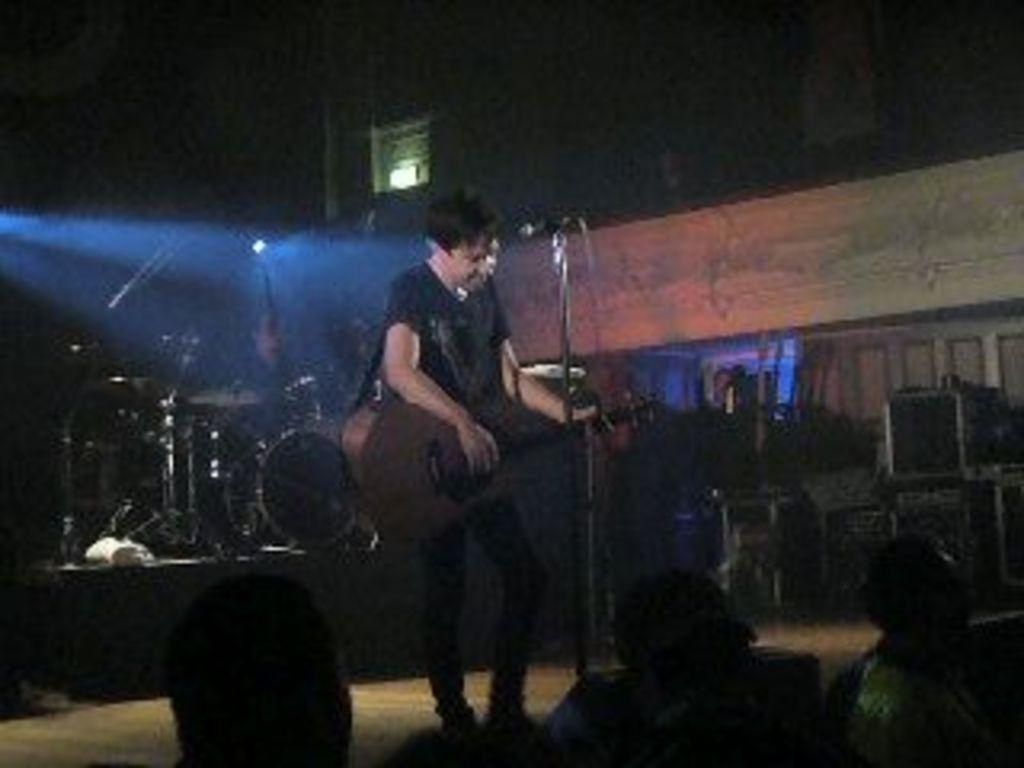Could you give a brief overview of what you see in this image? In this picture I can see a man standing and playing guitar and I can see a microphone and I can see drums in the back and few audience seated and I can see a light in the back. 